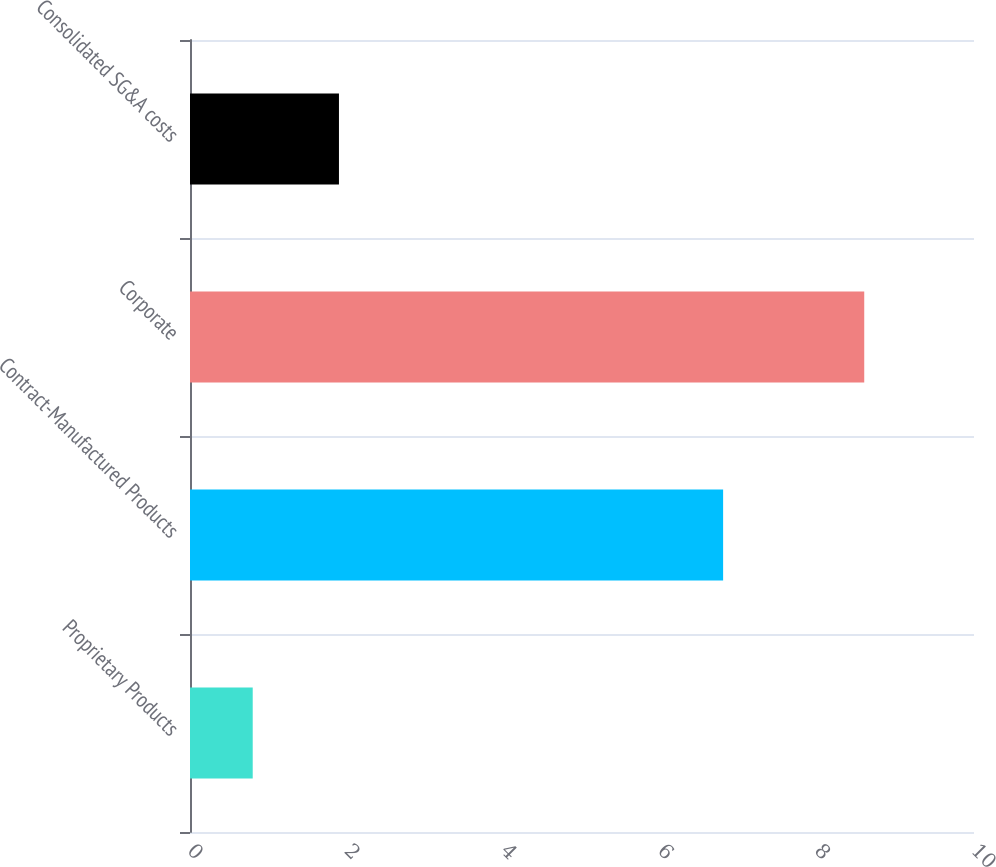Convert chart. <chart><loc_0><loc_0><loc_500><loc_500><bar_chart><fcel>Proprietary Products<fcel>Contract-Manufactured Products<fcel>Corporate<fcel>Consolidated SG&A costs<nl><fcel>0.8<fcel>6.8<fcel>8.6<fcel>1.9<nl></chart> 